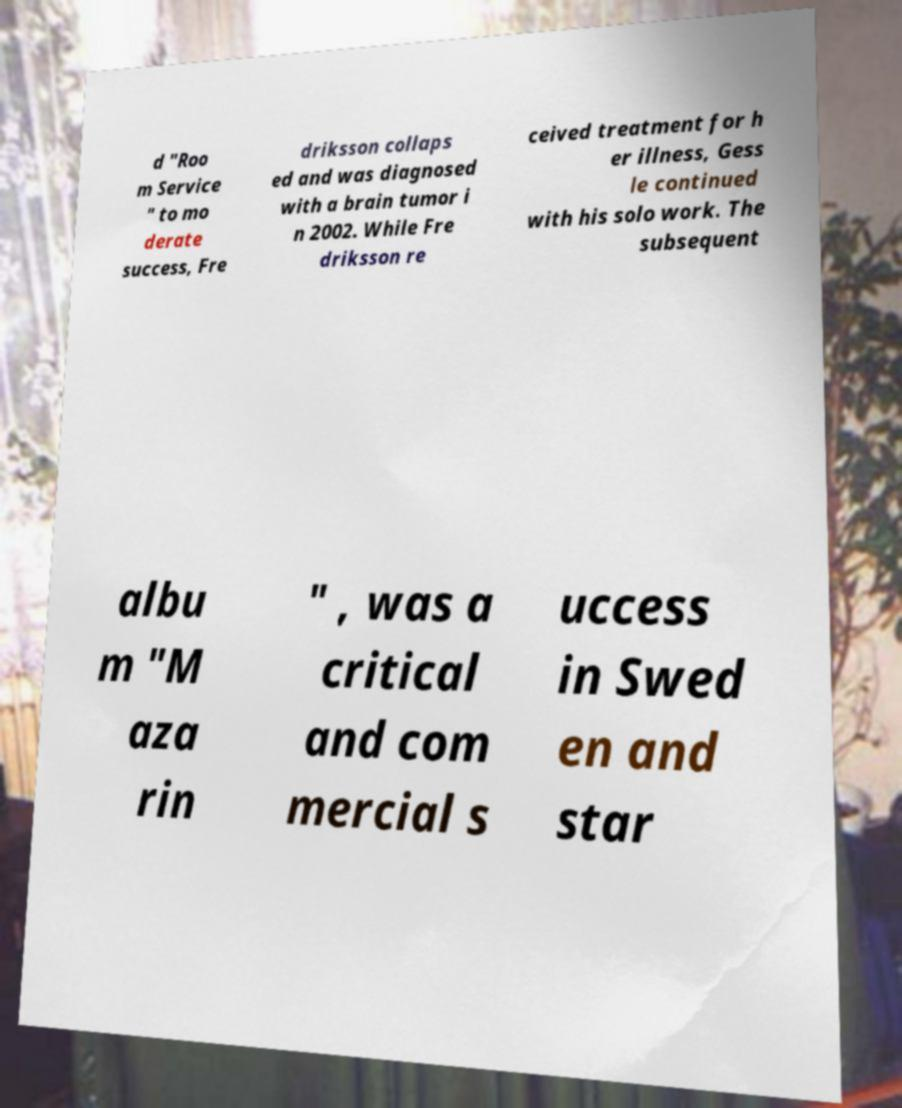What messages or text are displayed in this image? I need them in a readable, typed format. d "Roo m Service " to mo derate success, Fre driksson collaps ed and was diagnosed with a brain tumor i n 2002. While Fre driksson re ceived treatment for h er illness, Gess le continued with his solo work. The subsequent albu m "M aza rin " , was a critical and com mercial s uccess in Swed en and star 